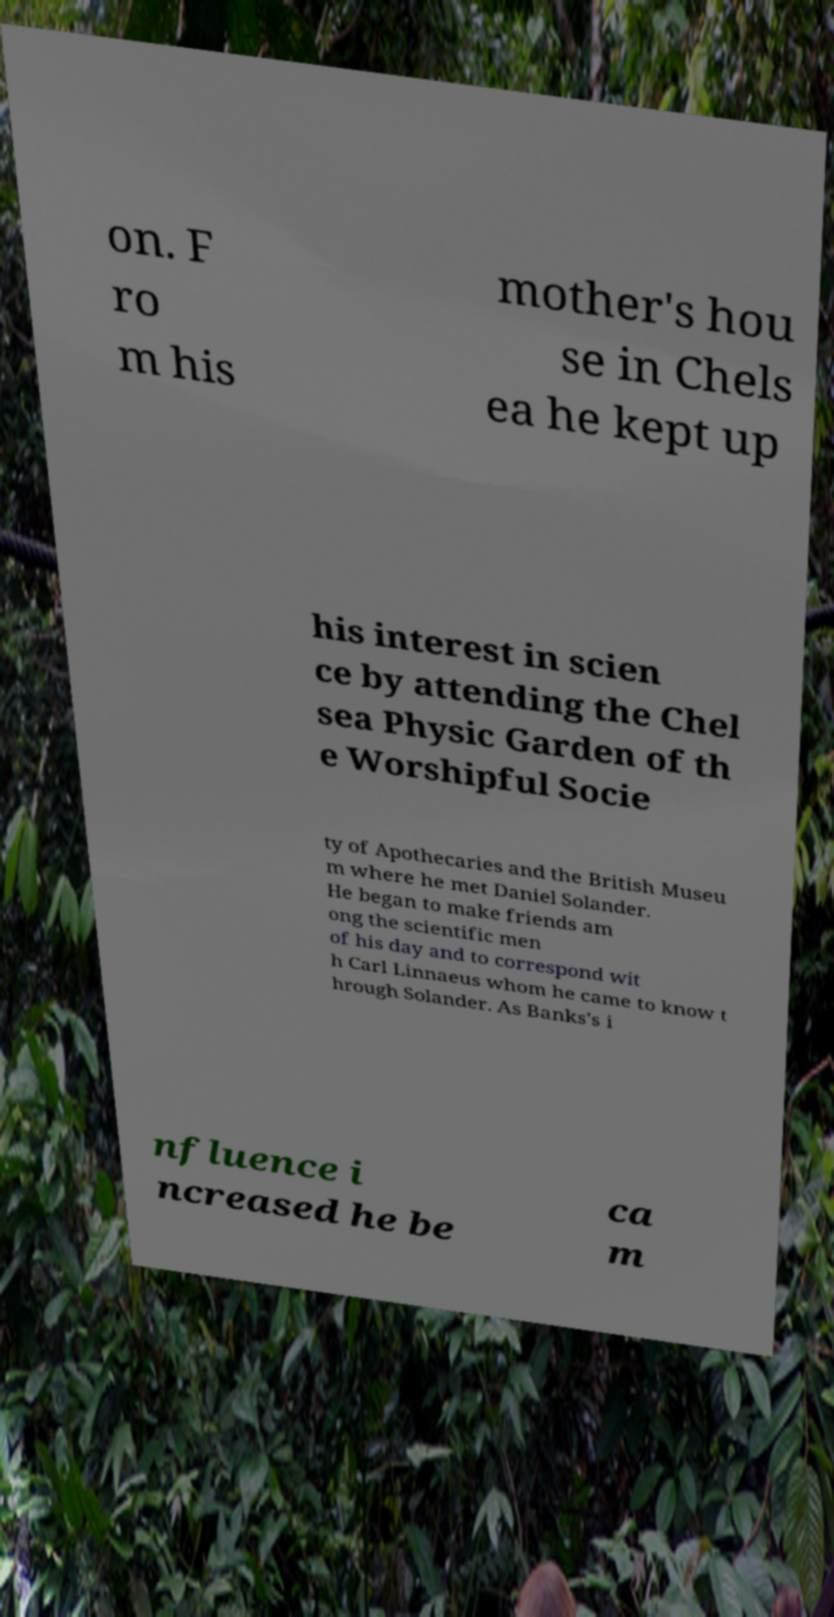Can you read and provide the text displayed in the image?This photo seems to have some interesting text. Can you extract and type it out for me? on. F ro m his mother's hou se in Chels ea he kept up his interest in scien ce by attending the Chel sea Physic Garden of th e Worshipful Socie ty of Apothecaries and the British Museu m where he met Daniel Solander. He began to make friends am ong the scientific men of his day and to correspond wit h Carl Linnaeus whom he came to know t hrough Solander. As Banks's i nfluence i ncreased he be ca m 